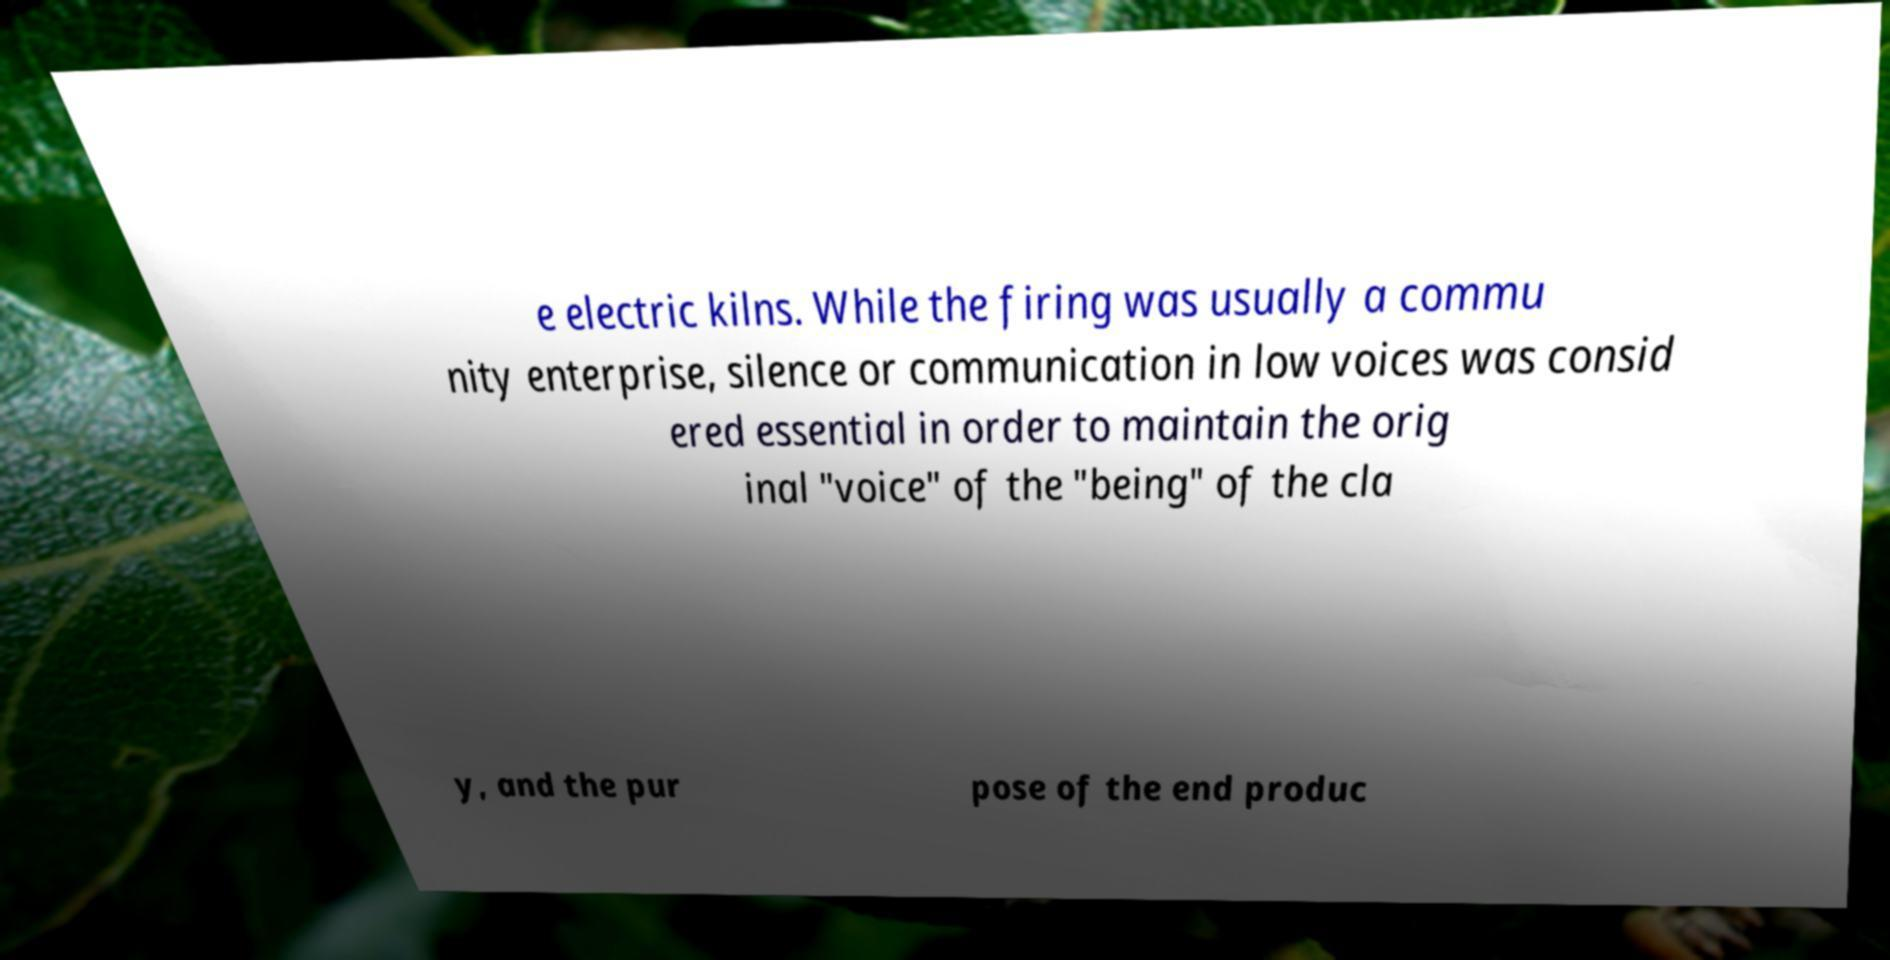Can you accurately transcribe the text from the provided image for me? e electric kilns. While the firing was usually a commu nity enterprise, silence or communication in low voices was consid ered essential in order to maintain the orig inal "voice" of the "being" of the cla y, and the pur pose of the end produc 